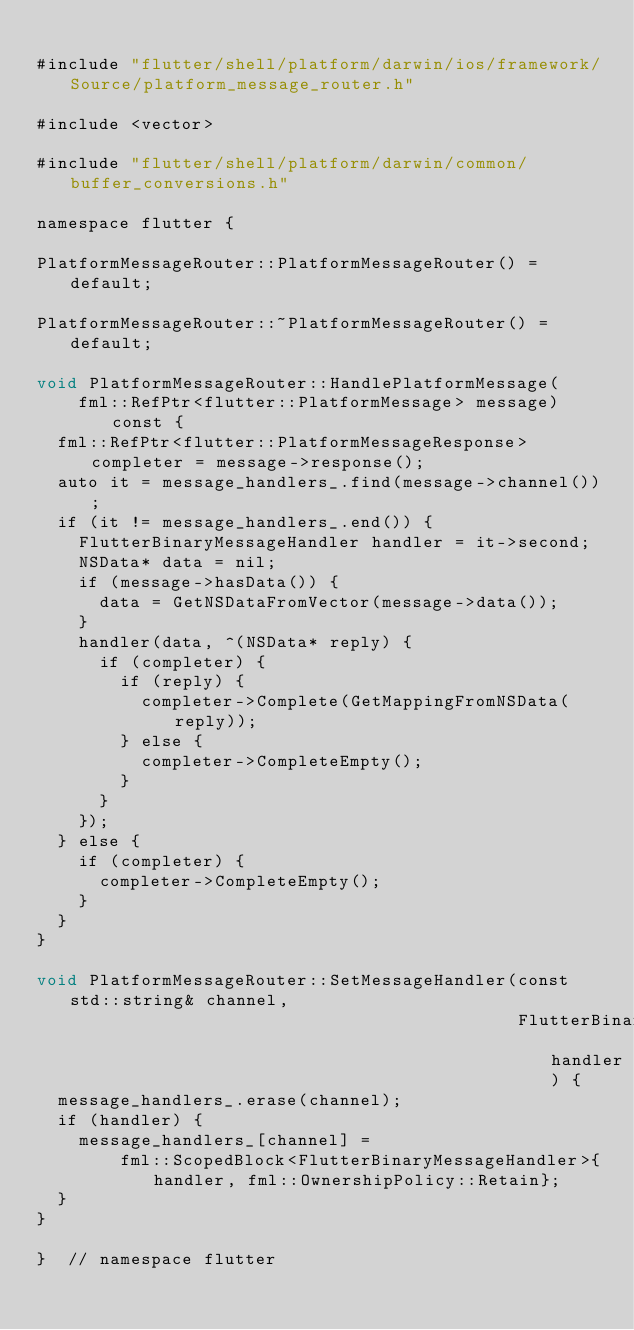<code> <loc_0><loc_0><loc_500><loc_500><_ObjectiveC_>
#include "flutter/shell/platform/darwin/ios/framework/Source/platform_message_router.h"

#include <vector>

#include "flutter/shell/platform/darwin/common/buffer_conversions.h"

namespace flutter {

PlatformMessageRouter::PlatformMessageRouter() = default;

PlatformMessageRouter::~PlatformMessageRouter() = default;

void PlatformMessageRouter::HandlePlatformMessage(
    fml::RefPtr<flutter::PlatformMessage> message) const {
  fml::RefPtr<flutter::PlatformMessageResponse> completer = message->response();
  auto it = message_handlers_.find(message->channel());
  if (it != message_handlers_.end()) {
    FlutterBinaryMessageHandler handler = it->second;
    NSData* data = nil;
    if (message->hasData()) {
      data = GetNSDataFromVector(message->data());
    }
    handler(data, ^(NSData* reply) {
      if (completer) {
        if (reply) {
          completer->Complete(GetMappingFromNSData(reply));
        } else {
          completer->CompleteEmpty();
        }
      }
    });
  } else {
    if (completer) {
      completer->CompleteEmpty();
    }
  }
}

void PlatformMessageRouter::SetMessageHandler(const std::string& channel,
                                              FlutterBinaryMessageHandler handler) {
  message_handlers_.erase(channel);
  if (handler) {
    message_handlers_[channel] =
        fml::ScopedBlock<FlutterBinaryMessageHandler>{handler, fml::OwnershipPolicy::Retain};
  }
}

}  // namespace flutter
</code> 